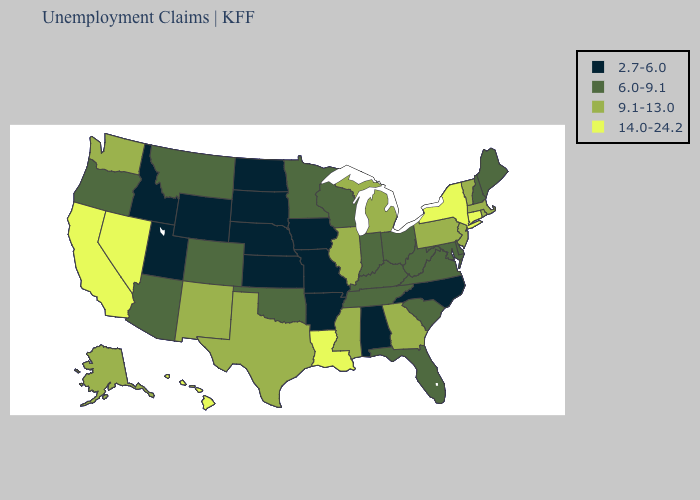Name the states that have a value in the range 9.1-13.0?
Be succinct. Alaska, Georgia, Illinois, Massachusetts, Michigan, Mississippi, New Jersey, New Mexico, Pennsylvania, Rhode Island, Texas, Vermont, Washington. Among the states that border Florida , which have the highest value?
Concise answer only. Georgia. Does the map have missing data?
Keep it brief. No. Name the states that have a value in the range 2.7-6.0?
Keep it brief. Alabama, Arkansas, Idaho, Iowa, Kansas, Missouri, Nebraska, North Carolina, North Dakota, South Dakota, Utah, Wyoming. Among the states that border Louisiana , which have the lowest value?
Be succinct. Arkansas. Does the first symbol in the legend represent the smallest category?
Short answer required. Yes. Does the map have missing data?
Write a very short answer. No. What is the value of Arizona?
Keep it brief. 6.0-9.1. What is the value of Minnesota?
Quick response, please. 6.0-9.1. What is the value of Arkansas?
Quick response, please. 2.7-6.0. Name the states that have a value in the range 6.0-9.1?
Write a very short answer. Arizona, Colorado, Delaware, Florida, Indiana, Kentucky, Maine, Maryland, Minnesota, Montana, New Hampshire, Ohio, Oklahoma, Oregon, South Carolina, Tennessee, Virginia, West Virginia, Wisconsin. What is the value of New York?
Short answer required. 14.0-24.2. What is the value of South Dakota?
Concise answer only. 2.7-6.0. Does the first symbol in the legend represent the smallest category?
Give a very brief answer. Yes. Name the states that have a value in the range 9.1-13.0?
Concise answer only. Alaska, Georgia, Illinois, Massachusetts, Michigan, Mississippi, New Jersey, New Mexico, Pennsylvania, Rhode Island, Texas, Vermont, Washington. 